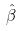<formula> <loc_0><loc_0><loc_500><loc_500>\hat { \beta }</formula> 